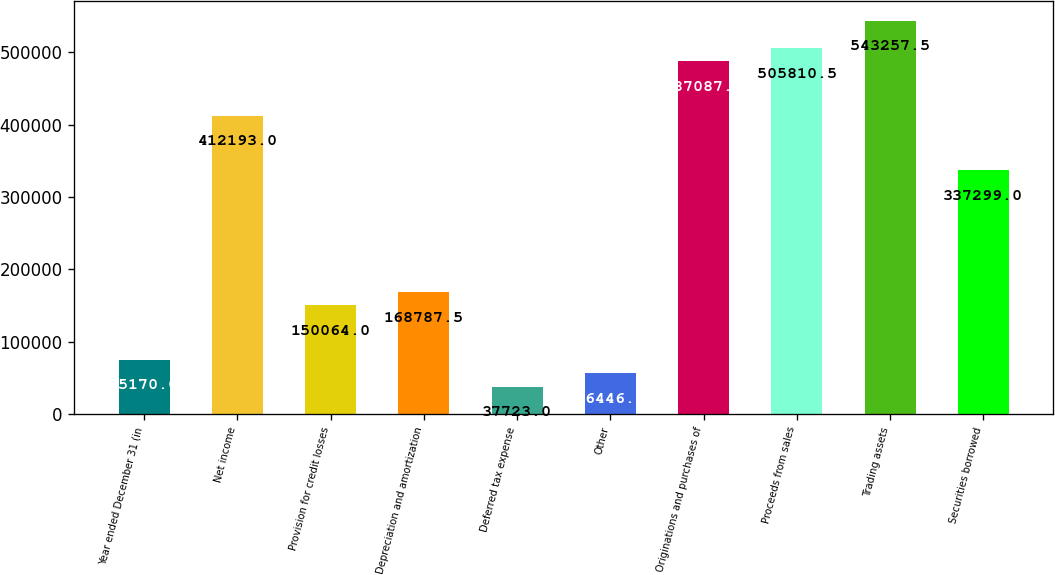Convert chart. <chart><loc_0><loc_0><loc_500><loc_500><bar_chart><fcel>Year ended December 31 (in<fcel>Net income<fcel>Provision for credit losses<fcel>Depreciation and amortization<fcel>Deferred tax expense<fcel>Other<fcel>Originations and purchases of<fcel>Proceeds from sales<fcel>Trading assets<fcel>Securities borrowed<nl><fcel>75170<fcel>412193<fcel>150064<fcel>168788<fcel>37723<fcel>56446.5<fcel>487087<fcel>505810<fcel>543258<fcel>337299<nl></chart> 